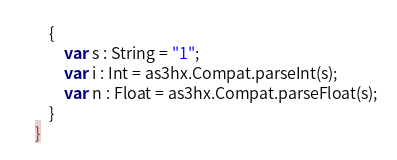Convert code to text. <code><loc_0><loc_0><loc_500><loc_500><_Haxe_>    {
        var s : String = "1";
        var i : Int = as3hx.Compat.parseInt(s);
        var n : Float = as3hx.Compat.parseFloat(s);
    }
}
</code> 